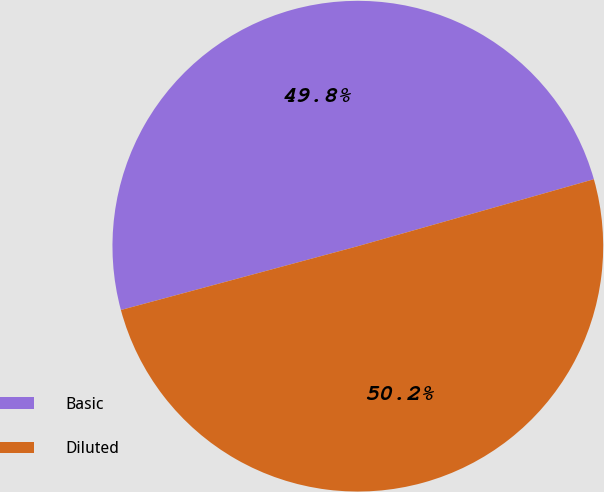Convert chart. <chart><loc_0><loc_0><loc_500><loc_500><pie_chart><fcel>Basic<fcel>Diluted<nl><fcel>49.79%<fcel>50.21%<nl></chart> 